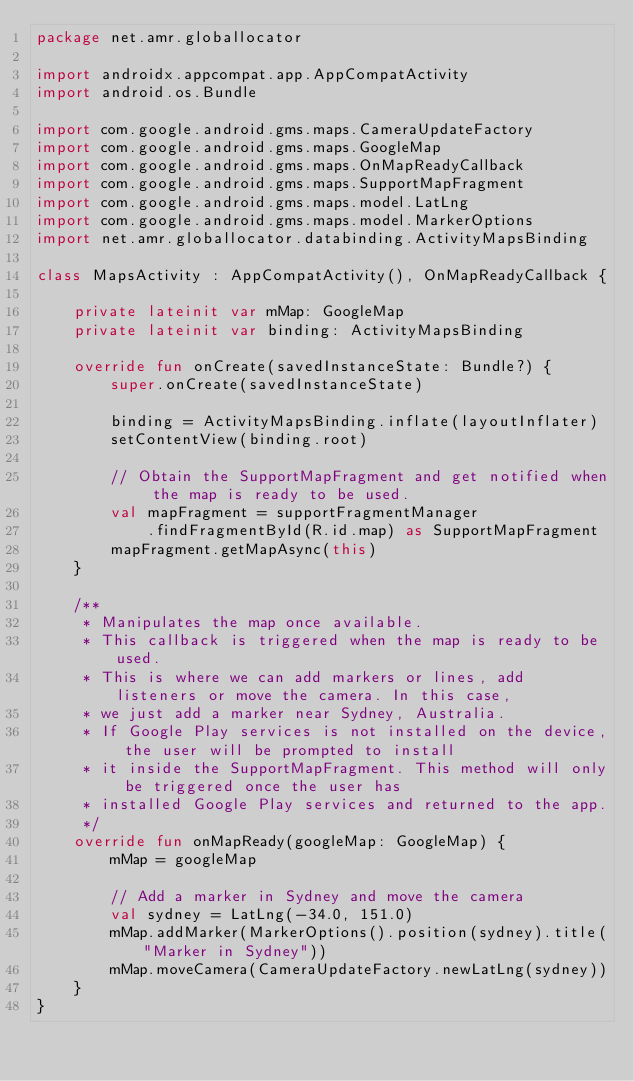Convert code to text. <code><loc_0><loc_0><loc_500><loc_500><_Kotlin_>package net.amr.globallocator

import androidx.appcompat.app.AppCompatActivity
import android.os.Bundle

import com.google.android.gms.maps.CameraUpdateFactory
import com.google.android.gms.maps.GoogleMap
import com.google.android.gms.maps.OnMapReadyCallback
import com.google.android.gms.maps.SupportMapFragment
import com.google.android.gms.maps.model.LatLng
import com.google.android.gms.maps.model.MarkerOptions
import net.amr.globallocator.databinding.ActivityMapsBinding

class MapsActivity : AppCompatActivity(), OnMapReadyCallback {

    private lateinit var mMap: GoogleMap
    private lateinit var binding: ActivityMapsBinding

    override fun onCreate(savedInstanceState: Bundle?) {
        super.onCreate(savedInstanceState)

        binding = ActivityMapsBinding.inflate(layoutInflater)
        setContentView(binding.root)

        // Obtain the SupportMapFragment and get notified when the map is ready to be used.
        val mapFragment = supportFragmentManager
            .findFragmentById(R.id.map) as SupportMapFragment
        mapFragment.getMapAsync(this)
    }

    /**
     * Manipulates the map once available.
     * This callback is triggered when the map is ready to be used.
     * This is where we can add markers or lines, add listeners or move the camera. In this case,
     * we just add a marker near Sydney, Australia.
     * If Google Play services is not installed on the device, the user will be prompted to install
     * it inside the SupportMapFragment. This method will only be triggered once the user has
     * installed Google Play services and returned to the app.
     */
    override fun onMapReady(googleMap: GoogleMap) {
        mMap = googleMap

        // Add a marker in Sydney and move the camera
        val sydney = LatLng(-34.0, 151.0)
        mMap.addMarker(MarkerOptions().position(sydney).title("Marker in Sydney"))
        mMap.moveCamera(CameraUpdateFactory.newLatLng(sydney))
    }
}</code> 